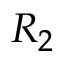Convert formula to latex. <formula><loc_0><loc_0><loc_500><loc_500>R _ { 2 }</formula> 